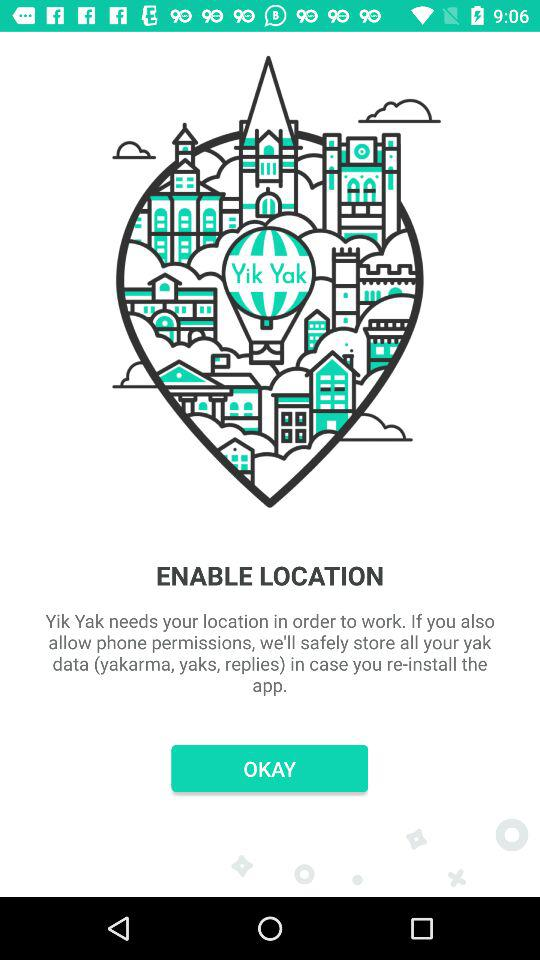What is the name of the application? The name of the application is "Yik Yak". 